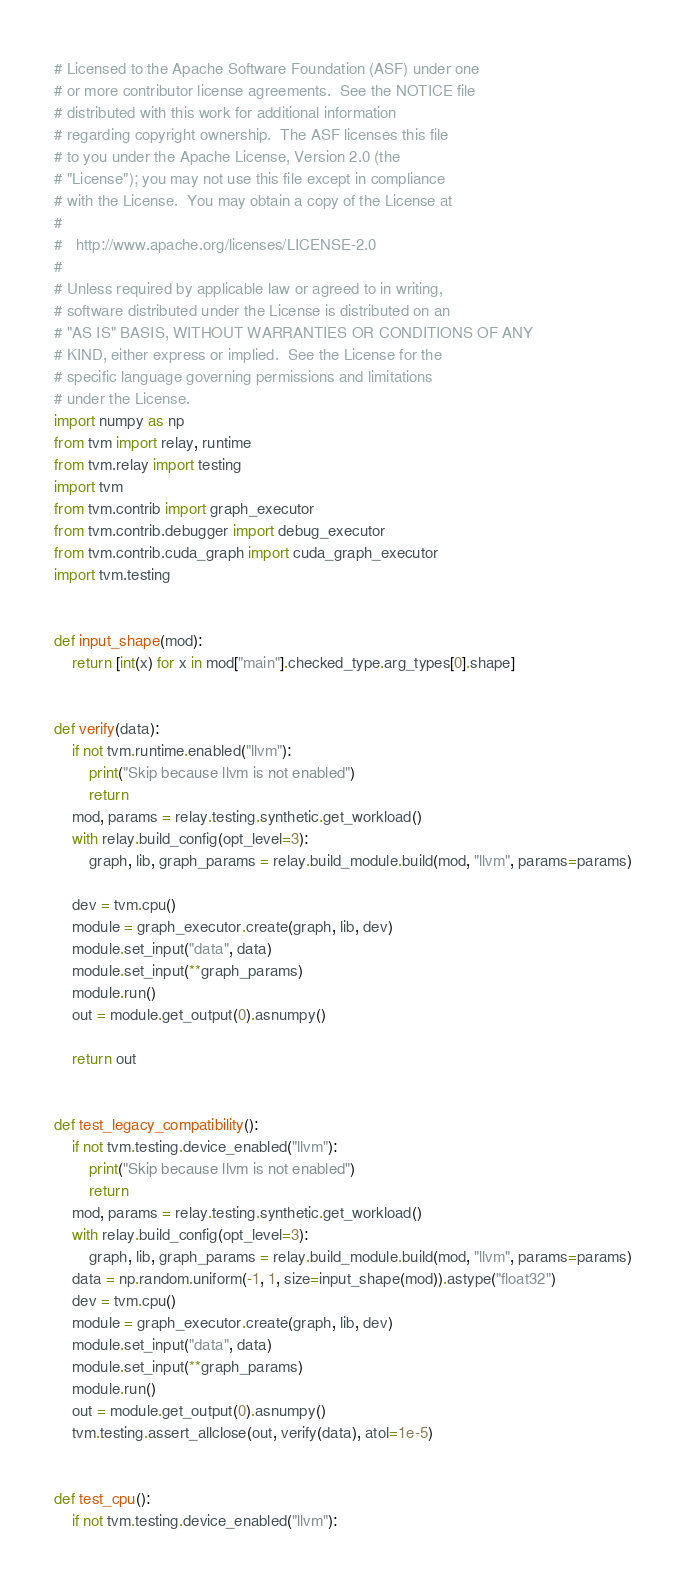<code> <loc_0><loc_0><loc_500><loc_500><_Python_># Licensed to the Apache Software Foundation (ASF) under one
# or more contributor license agreements.  See the NOTICE file
# distributed with this work for additional information
# regarding copyright ownership.  The ASF licenses this file
# to you under the Apache License, Version 2.0 (the
# "License"); you may not use this file except in compliance
# with the License.  You may obtain a copy of the License at
#
#   http://www.apache.org/licenses/LICENSE-2.0
#
# Unless required by applicable law or agreed to in writing,
# software distributed under the License is distributed on an
# "AS IS" BASIS, WITHOUT WARRANTIES OR CONDITIONS OF ANY
# KIND, either express or implied.  See the License for the
# specific language governing permissions and limitations
# under the License.
import numpy as np
from tvm import relay, runtime
from tvm.relay import testing
import tvm
from tvm.contrib import graph_executor
from tvm.contrib.debugger import debug_executor
from tvm.contrib.cuda_graph import cuda_graph_executor
import tvm.testing


def input_shape(mod):
    return [int(x) for x in mod["main"].checked_type.arg_types[0].shape]


def verify(data):
    if not tvm.runtime.enabled("llvm"):
        print("Skip because llvm is not enabled")
        return
    mod, params = relay.testing.synthetic.get_workload()
    with relay.build_config(opt_level=3):
        graph, lib, graph_params = relay.build_module.build(mod, "llvm", params=params)

    dev = tvm.cpu()
    module = graph_executor.create(graph, lib, dev)
    module.set_input("data", data)
    module.set_input(**graph_params)
    module.run()
    out = module.get_output(0).asnumpy()

    return out


def test_legacy_compatibility():
    if not tvm.testing.device_enabled("llvm"):
        print("Skip because llvm is not enabled")
        return
    mod, params = relay.testing.synthetic.get_workload()
    with relay.build_config(opt_level=3):
        graph, lib, graph_params = relay.build_module.build(mod, "llvm", params=params)
    data = np.random.uniform(-1, 1, size=input_shape(mod)).astype("float32")
    dev = tvm.cpu()
    module = graph_executor.create(graph, lib, dev)
    module.set_input("data", data)
    module.set_input(**graph_params)
    module.run()
    out = module.get_output(0).asnumpy()
    tvm.testing.assert_allclose(out, verify(data), atol=1e-5)


def test_cpu():
    if not tvm.testing.device_enabled("llvm"):</code> 